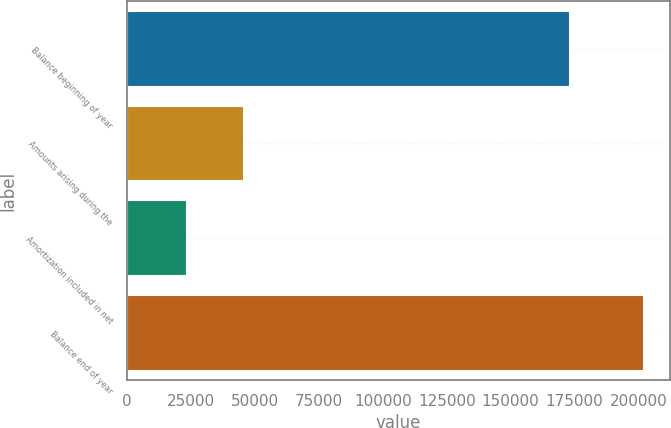<chart> <loc_0><loc_0><loc_500><loc_500><bar_chart><fcel>Balance beginning of year<fcel>Amounts arising during the<fcel>Amortization included in net<fcel>Balance end of year<nl><fcel>173029<fcel>45804<fcel>23313<fcel>202292<nl></chart> 